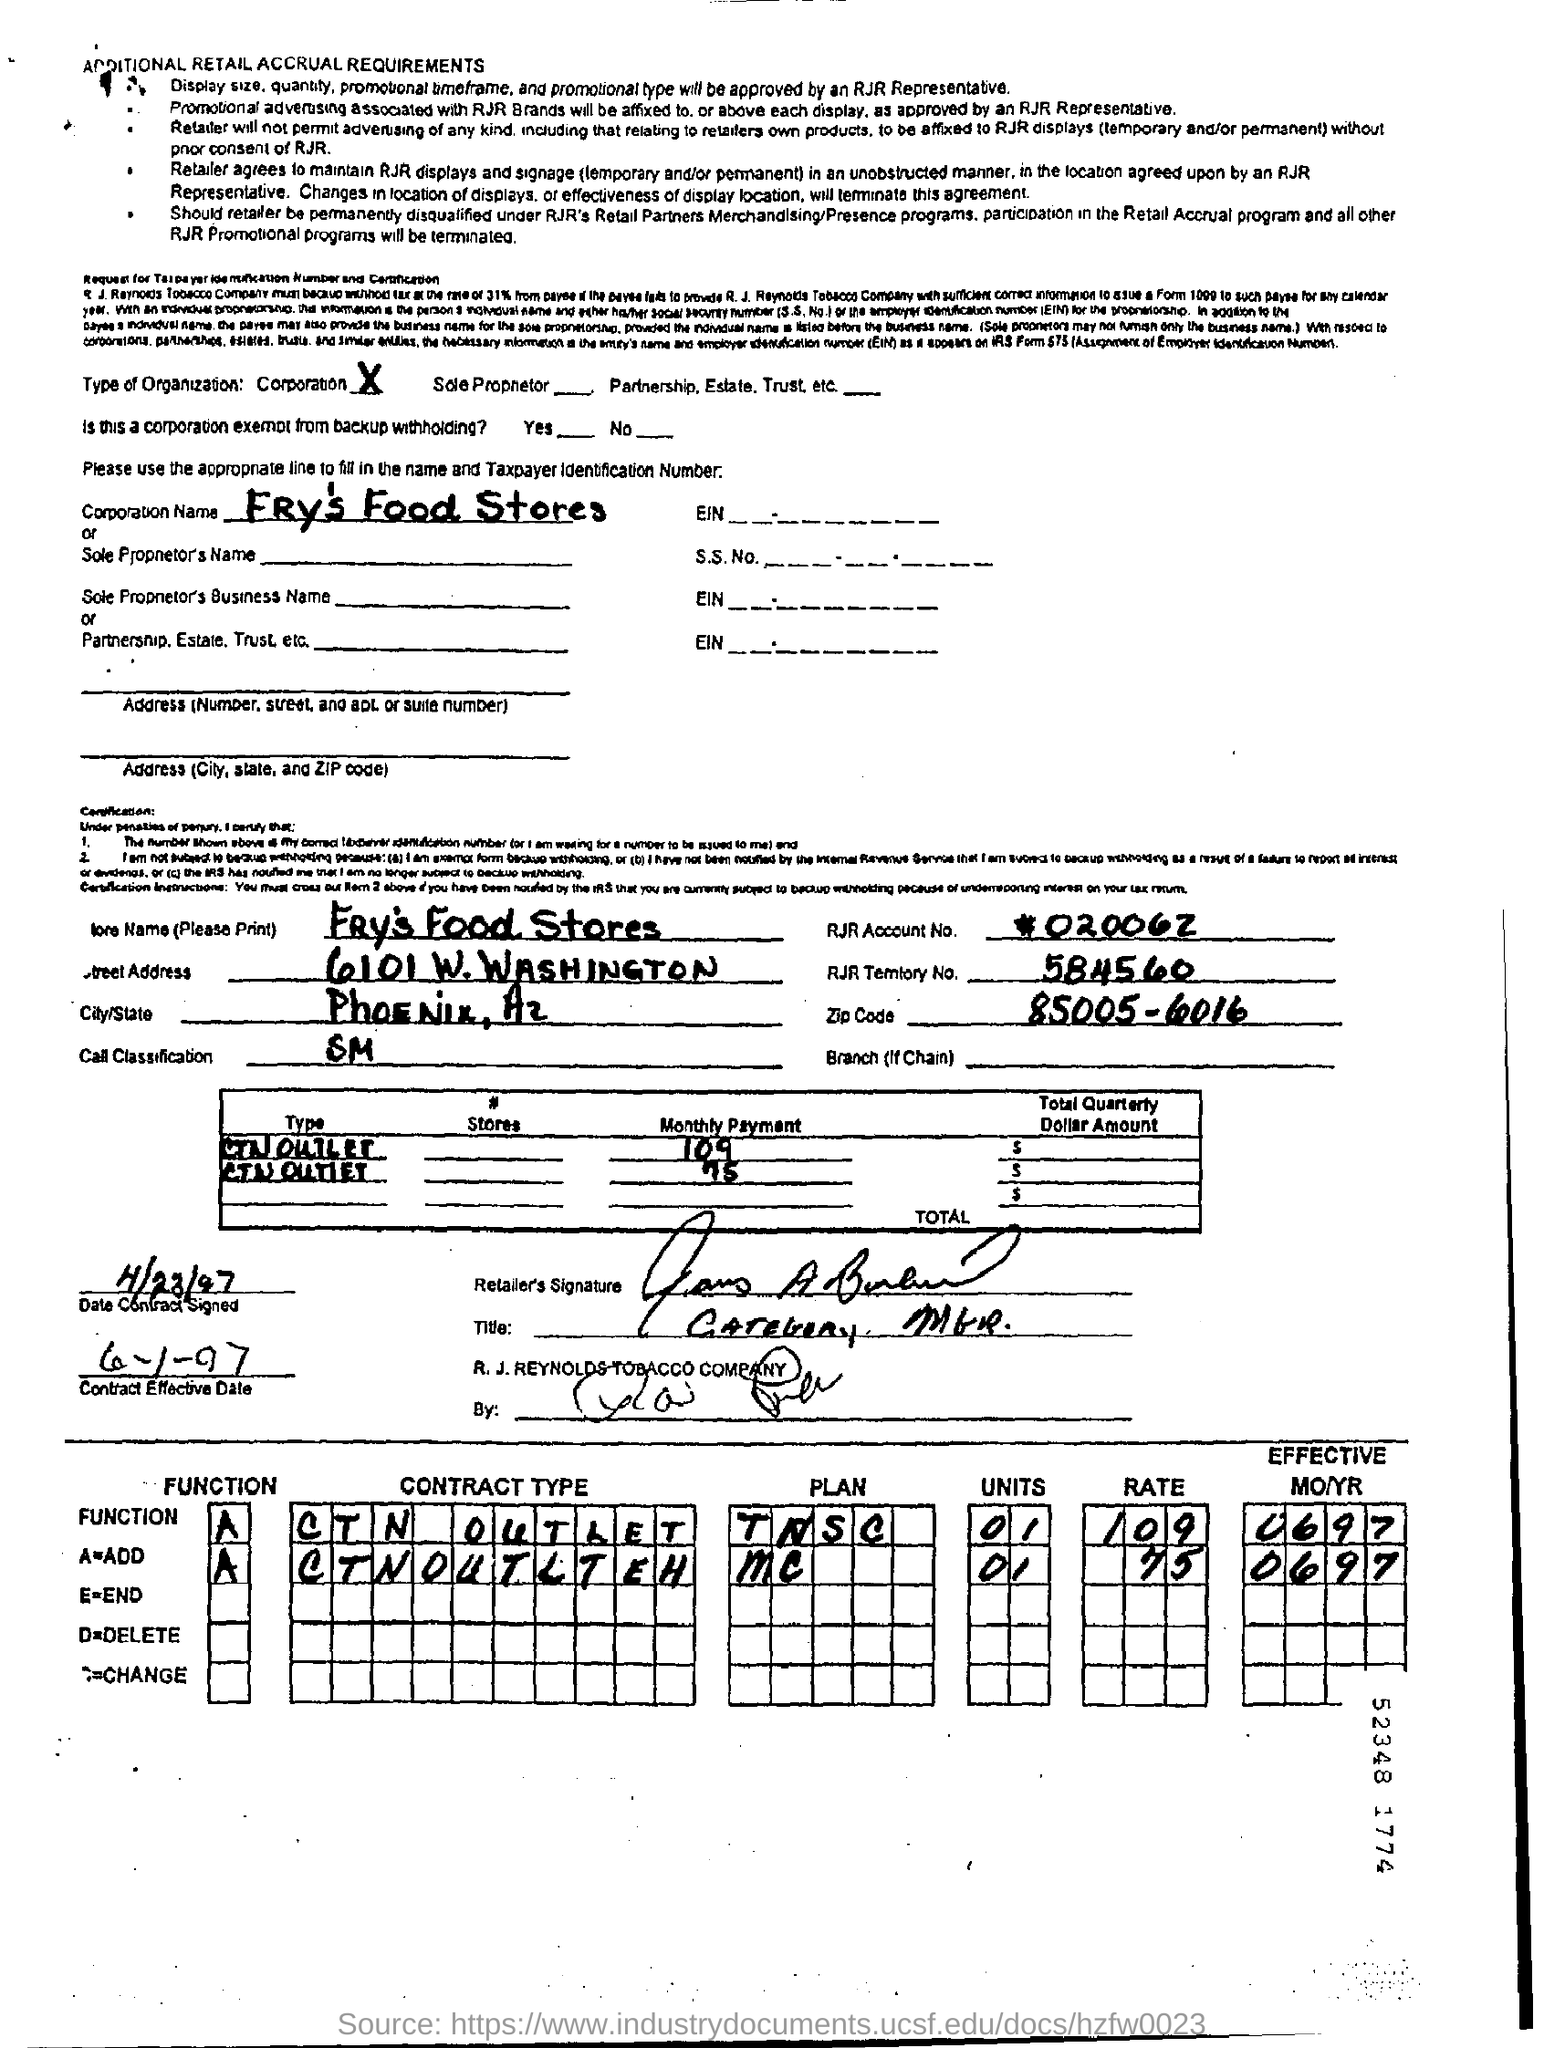Highlight a few significant elements in this photo. The zip code provided in the document is 85005-6016. The contract's effective date, as per the document, is June 1, 1997. On April 23, 1997, the date of the contract signing was taken place. The document provides the name of a store, which is Fry's Food Stores. Please provide the RJR territory number mentioned in the document, which is 584560... 